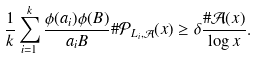<formula> <loc_0><loc_0><loc_500><loc_500>\frac { 1 } { k } \sum _ { i = 1 } ^ { k } \frac { \phi ( a _ { i } ) \phi ( B ) } { a _ { i } B } \# \mathcal { P } _ { L _ { i } , \mathcal { A } } ( x ) \geq \delta \frac { \# \mathcal { A } ( x ) } { \log { x } } .</formula> 